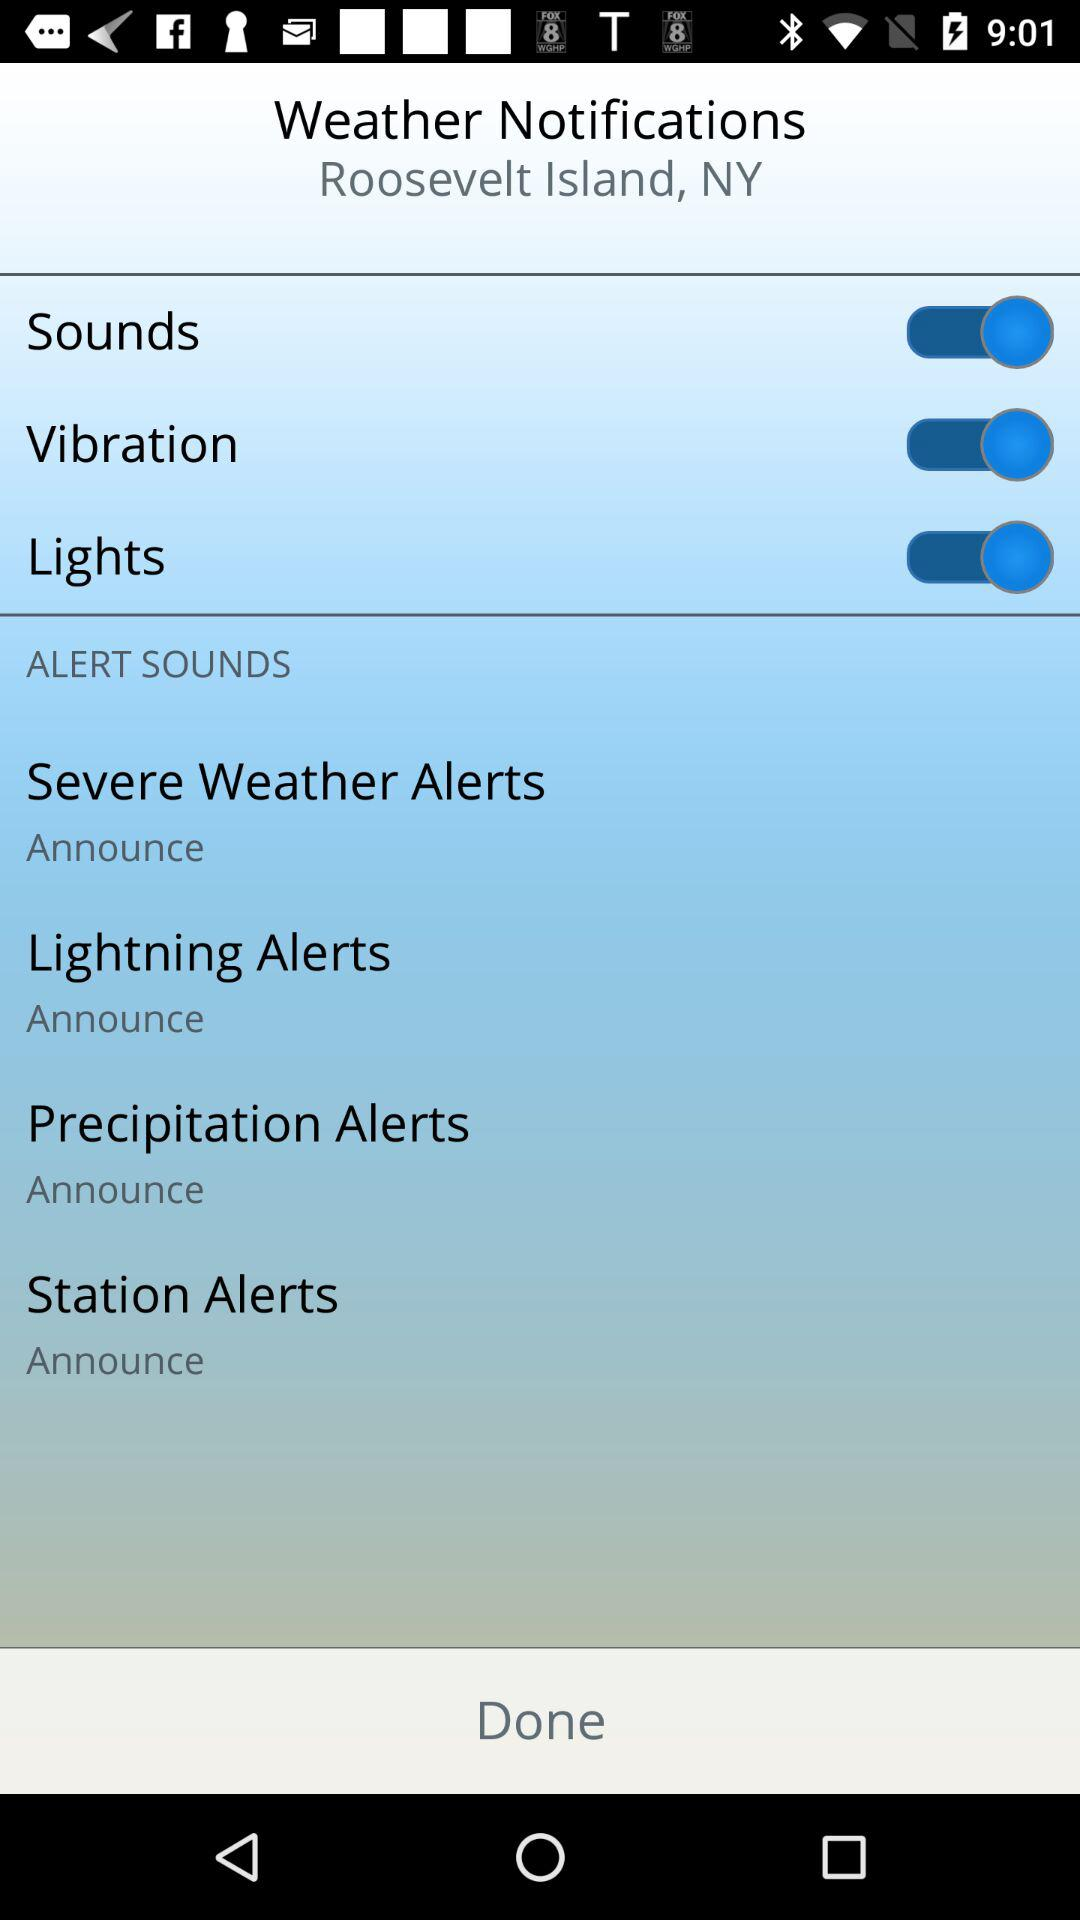How many alert sounds are available?
Answer the question using a single word or phrase. 4 